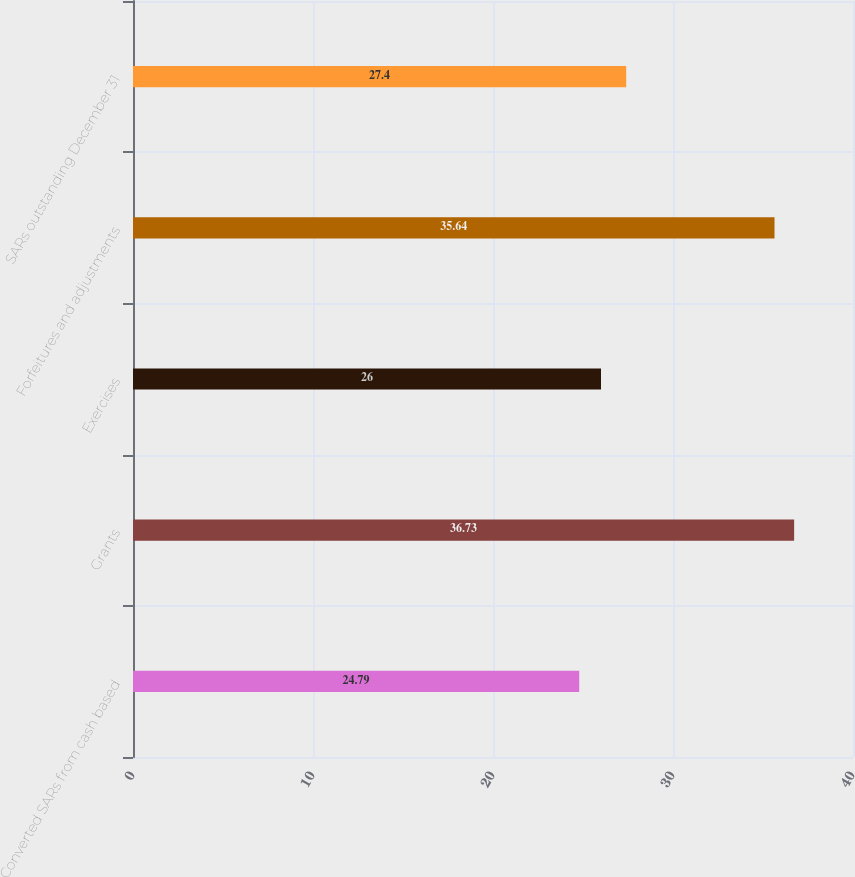Convert chart to OTSL. <chart><loc_0><loc_0><loc_500><loc_500><bar_chart><fcel>Converted SARs from cash based<fcel>Grants<fcel>Exercises<fcel>Forfeitures and adjustments<fcel>SARs outstanding December 31<nl><fcel>24.79<fcel>36.73<fcel>26<fcel>35.64<fcel>27.4<nl></chart> 